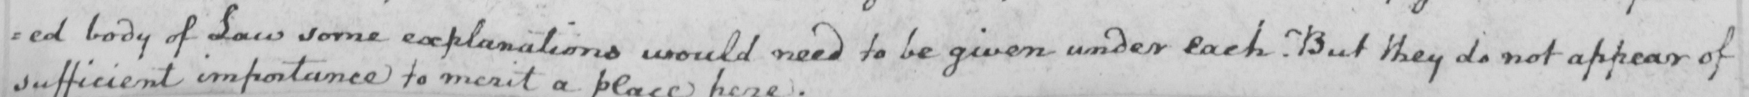What text is written in this handwritten line? : ed body of Law some explanations would need to be given under each . But they do not appear of 